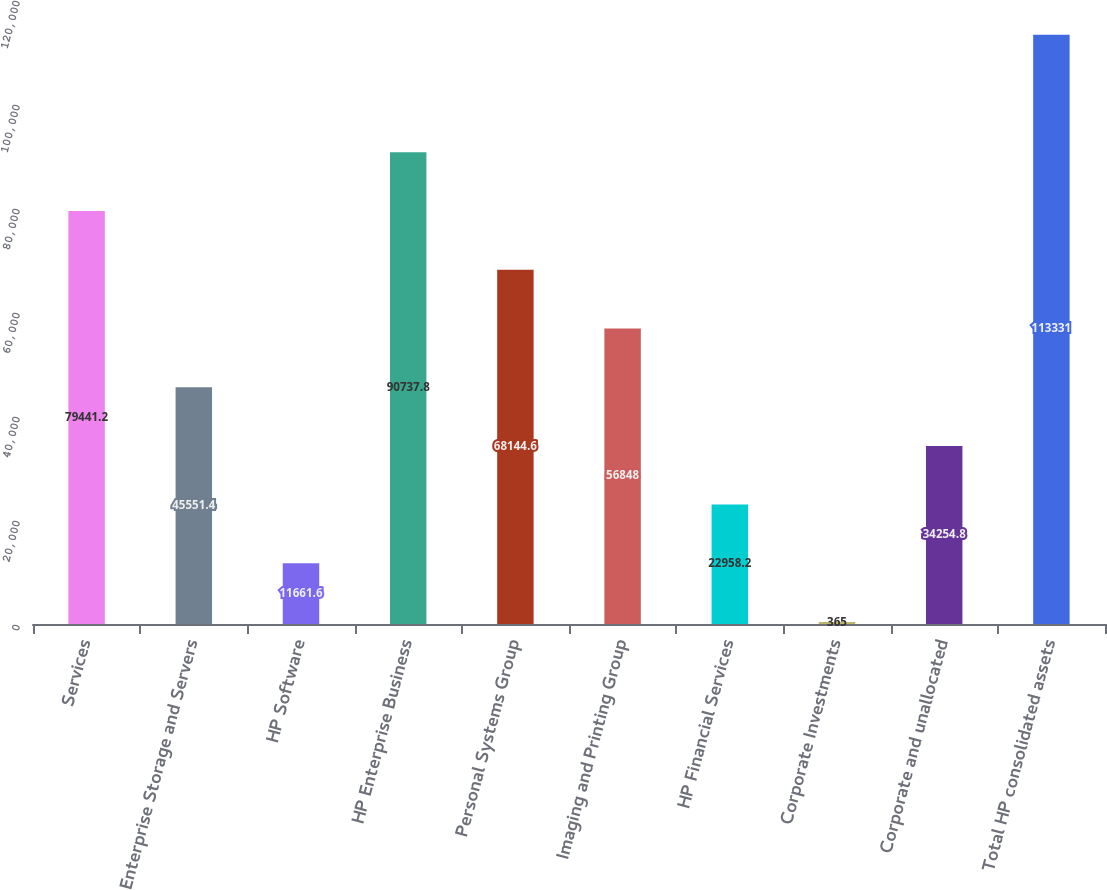Convert chart. <chart><loc_0><loc_0><loc_500><loc_500><bar_chart><fcel>Services<fcel>Enterprise Storage and Servers<fcel>HP Software<fcel>HP Enterprise Business<fcel>Personal Systems Group<fcel>Imaging and Printing Group<fcel>HP Financial Services<fcel>Corporate Investments<fcel>Corporate and unallocated<fcel>Total HP consolidated assets<nl><fcel>79441.2<fcel>45551.4<fcel>11661.6<fcel>90737.8<fcel>68144.6<fcel>56848<fcel>22958.2<fcel>365<fcel>34254.8<fcel>113331<nl></chart> 